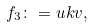<formula> <loc_0><loc_0><loc_500><loc_500>f _ { 3 } \colon = u k v ,</formula> 